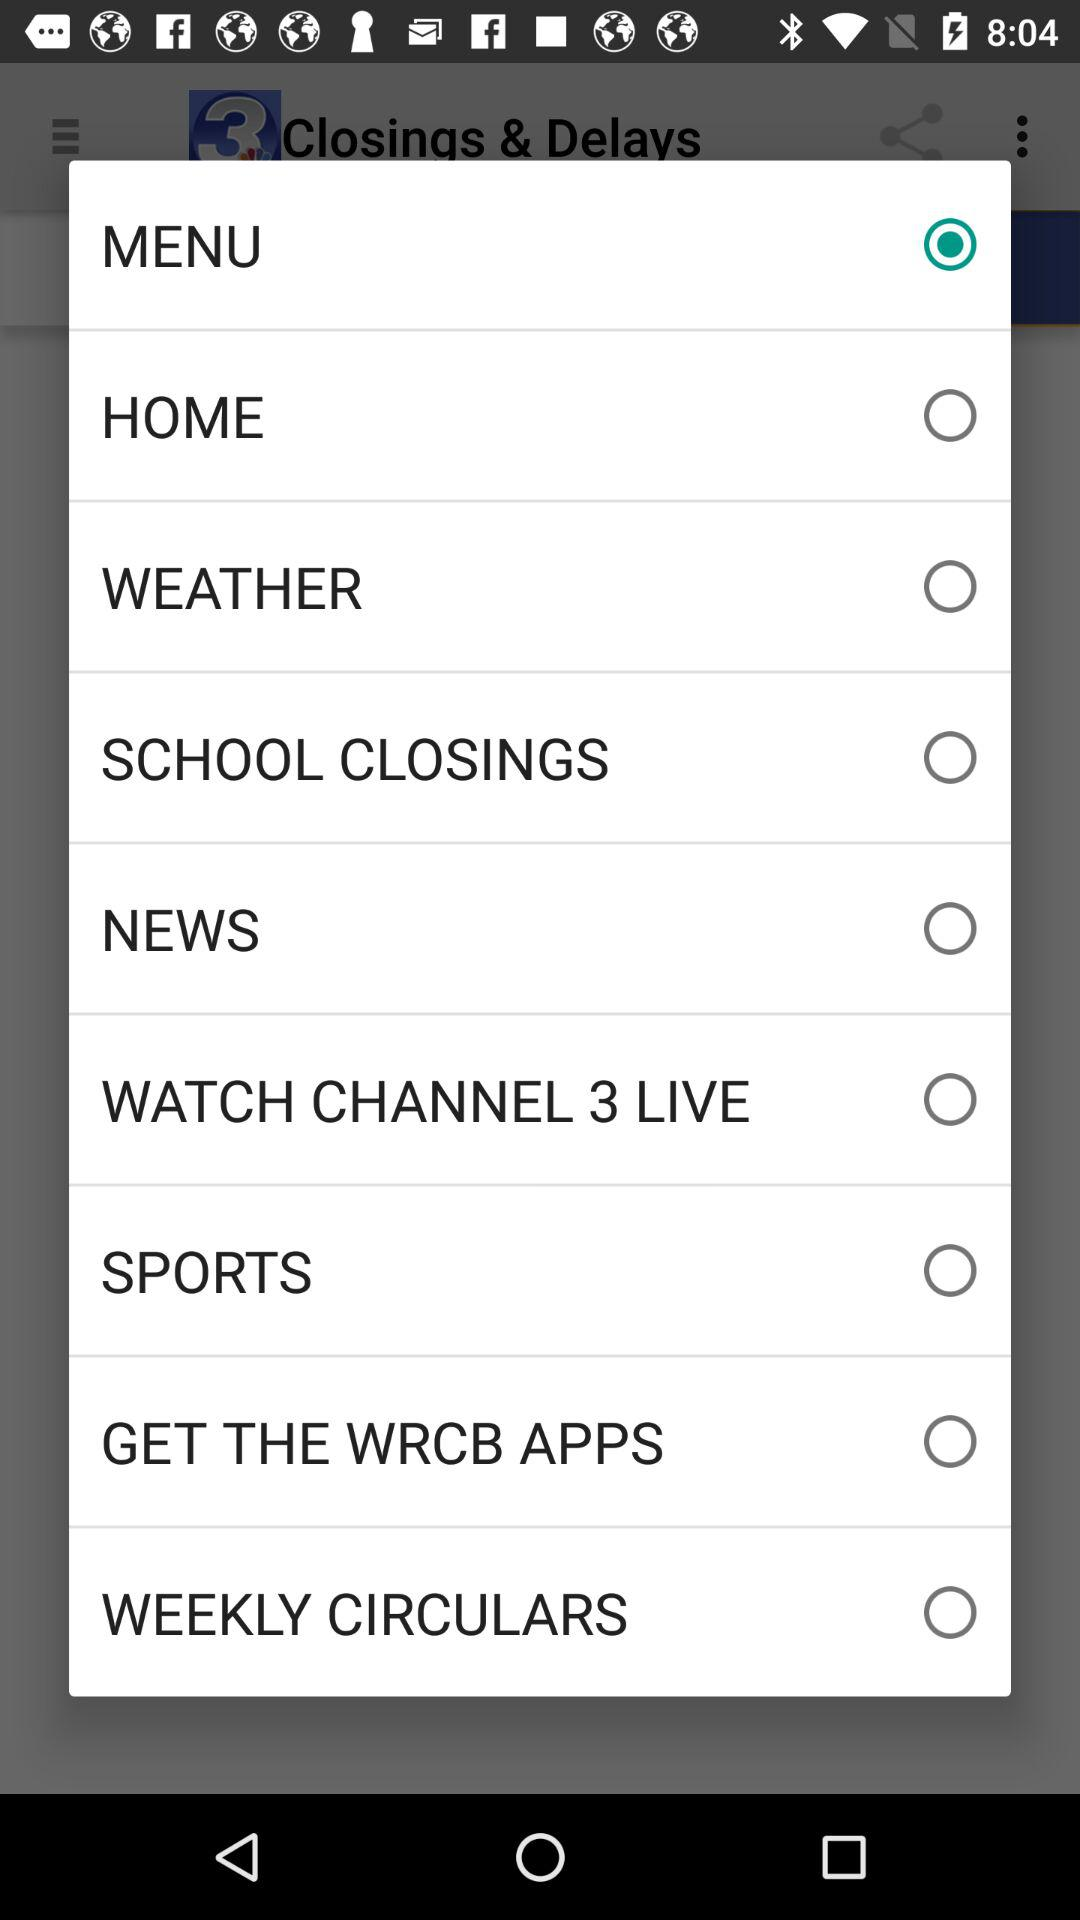Which option is selected? The selected option is "MENU". 